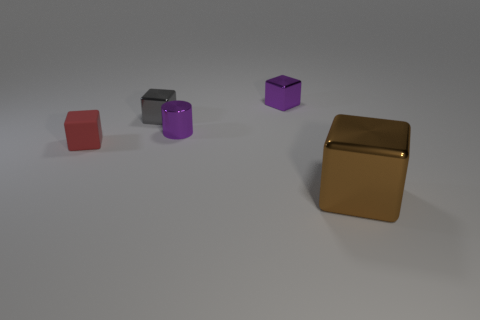Subtract 1 blocks. How many blocks are left? 3 Add 3 small gray shiny cubes. How many objects exist? 8 Subtract all cubes. How many objects are left? 1 Subtract all big brown objects. Subtract all big red matte balls. How many objects are left? 4 Add 4 red objects. How many red objects are left? 5 Add 4 big things. How many big things exist? 5 Subtract 0 gray balls. How many objects are left? 5 